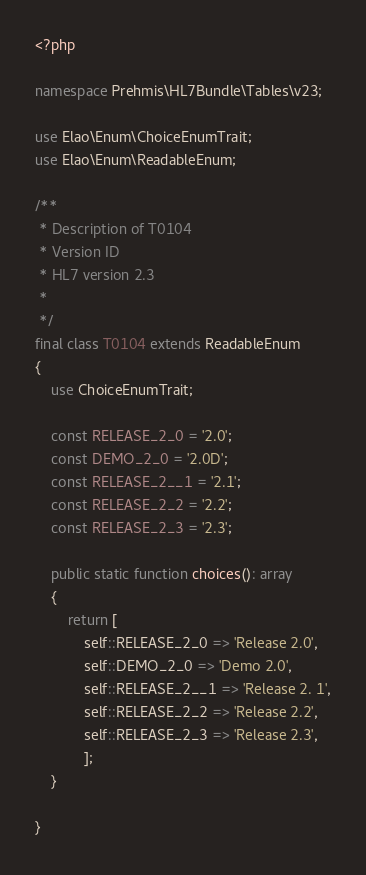Convert code to text. <code><loc_0><loc_0><loc_500><loc_500><_PHP_><?php
    
namespace Prehmis\HL7Bundle\Tables\v23;

use Elao\Enum\ChoiceEnumTrait;
use Elao\Enum\ReadableEnum;

/**
 * Description of T0104
 * Version ID
 * HL7 version 2.3
 *
 */
final class T0104 extends ReadableEnum
{
    use ChoiceEnumTrait;

    const RELEASE_2_0 = '2.0';
    const DEMO_2_0 = '2.0D';
    const RELEASE_2__1 = '2.1';
    const RELEASE_2_2 = '2.2';
    const RELEASE_2_3 = '2.3';
            
    public static function choices(): array
    {
        return [
            self::RELEASE_2_0 => 'Release 2.0',
            self::DEMO_2_0 => 'Demo 2.0',
            self::RELEASE_2__1 => 'Release 2. 1',
            self::RELEASE_2_2 => 'Release 2.2',
            self::RELEASE_2_3 => 'Release 2.3',
            ];
    }
      
}</code> 